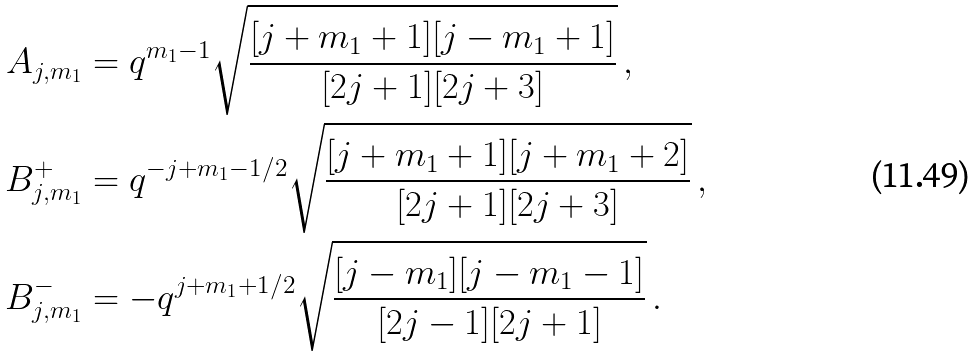Convert formula to latex. <formula><loc_0><loc_0><loc_500><loc_500>A _ { j , m _ { 1 } } & = q ^ { m _ { 1 } - 1 } \sqrt { \frac { [ j + m _ { 1 } + 1 ] [ j - m _ { 1 } + 1 ] } { [ 2 j + 1 ] [ 2 j + 3 ] } } \, , \\ B ^ { + } _ { j , m _ { 1 } } & = q ^ { - j + m _ { 1 } - 1 / 2 } \sqrt { \frac { [ j + m _ { 1 } + 1 ] [ j + m _ { 1 } + 2 ] } { [ 2 j + 1 ] [ 2 j + 3 ] } } \, , \\ B ^ { - } _ { j , m _ { 1 } } & = - q ^ { j + m _ { 1 } + 1 / 2 } \sqrt { \frac { [ j - m _ { 1 } ] [ j - m _ { 1 } - 1 ] } { [ 2 j - 1 ] [ 2 j + 1 ] } } \, .</formula> 